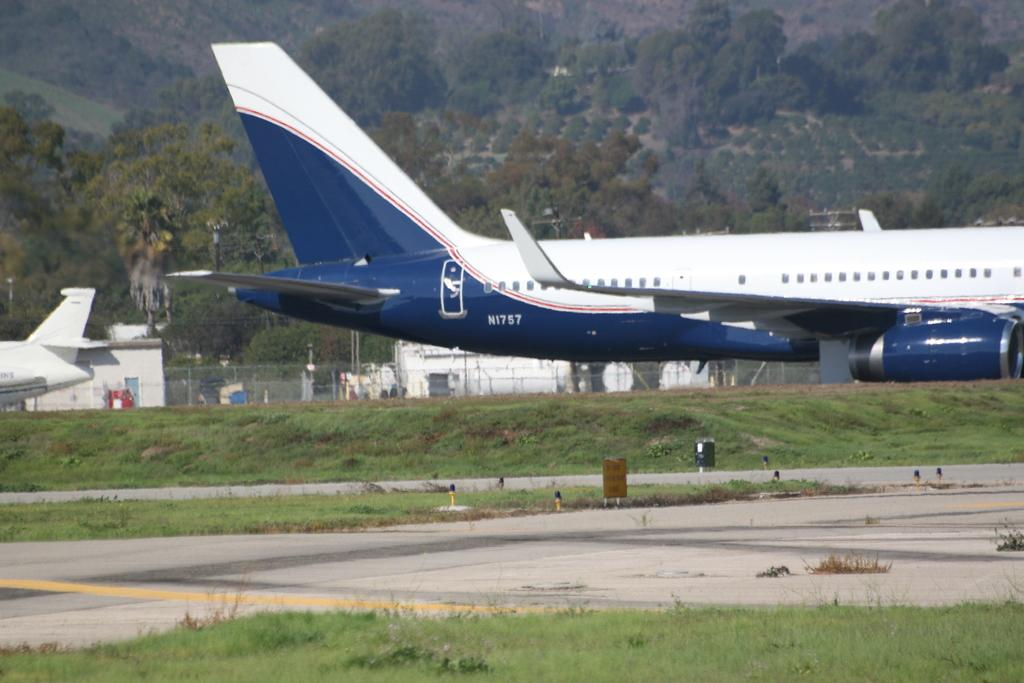<image>
Create a compact narrative representing the image presented. A plane with the call numbers N1757 is parked on concrete. 